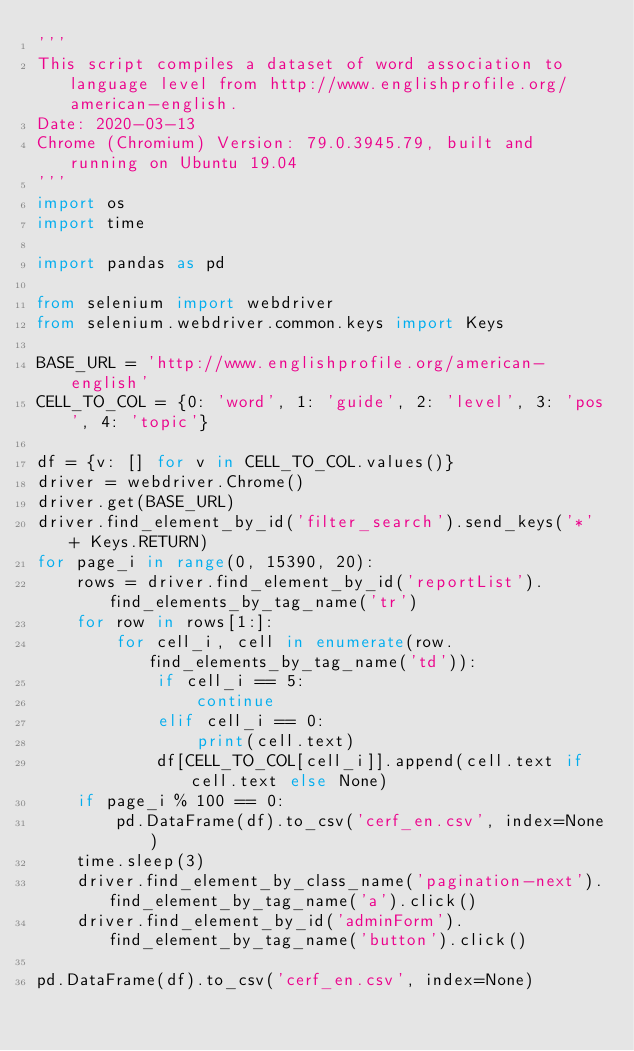<code> <loc_0><loc_0><loc_500><loc_500><_Python_>'''
This script compiles a dataset of word association to language level from http://www.englishprofile.org/american-english.
Date: 2020-03-13
Chrome (Chromium) Version: 79.0.3945.79, built and running on Ubuntu 19.04 
'''
import os
import time

import pandas as pd

from selenium import webdriver
from selenium.webdriver.common.keys import Keys

BASE_URL = 'http://www.englishprofile.org/american-english'
CELL_TO_COL = {0: 'word', 1: 'guide', 2: 'level', 3: 'pos', 4: 'topic'}

df = {v: [] for v in CELL_TO_COL.values()}
driver = webdriver.Chrome()
driver.get(BASE_URL)
driver.find_element_by_id('filter_search').send_keys('*' + Keys.RETURN)
for page_i in range(0, 15390, 20):
    rows = driver.find_element_by_id('reportList').find_elements_by_tag_name('tr')
    for row in rows[1:]:
        for cell_i, cell in enumerate(row.find_elements_by_tag_name('td')):
            if cell_i == 5:
                continue
            elif cell_i == 0:
                print(cell.text)
            df[CELL_TO_COL[cell_i]].append(cell.text if cell.text else None)
    if page_i % 100 == 0:
        pd.DataFrame(df).to_csv('cerf_en.csv', index=None)
    time.sleep(3)
    driver.find_element_by_class_name('pagination-next').find_element_by_tag_name('a').click()
    driver.find_element_by_id('adminForm').find_element_by_tag_name('button').click()

pd.DataFrame(df).to_csv('cerf_en.csv', index=None)
</code> 